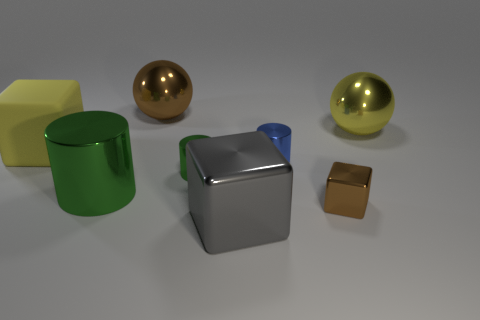Add 2 tiny cylinders. How many objects exist? 10 Subtract all spheres. How many objects are left? 6 Subtract 0 blue balls. How many objects are left? 8 Subtract all yellow rubber blocks. Subtract all small green metallic things. How many objects are left? 6 Add 1 big green things. How many big green things are left? 2 Add 2 yellow cylinders. How many yellow cylinders exist? 2 